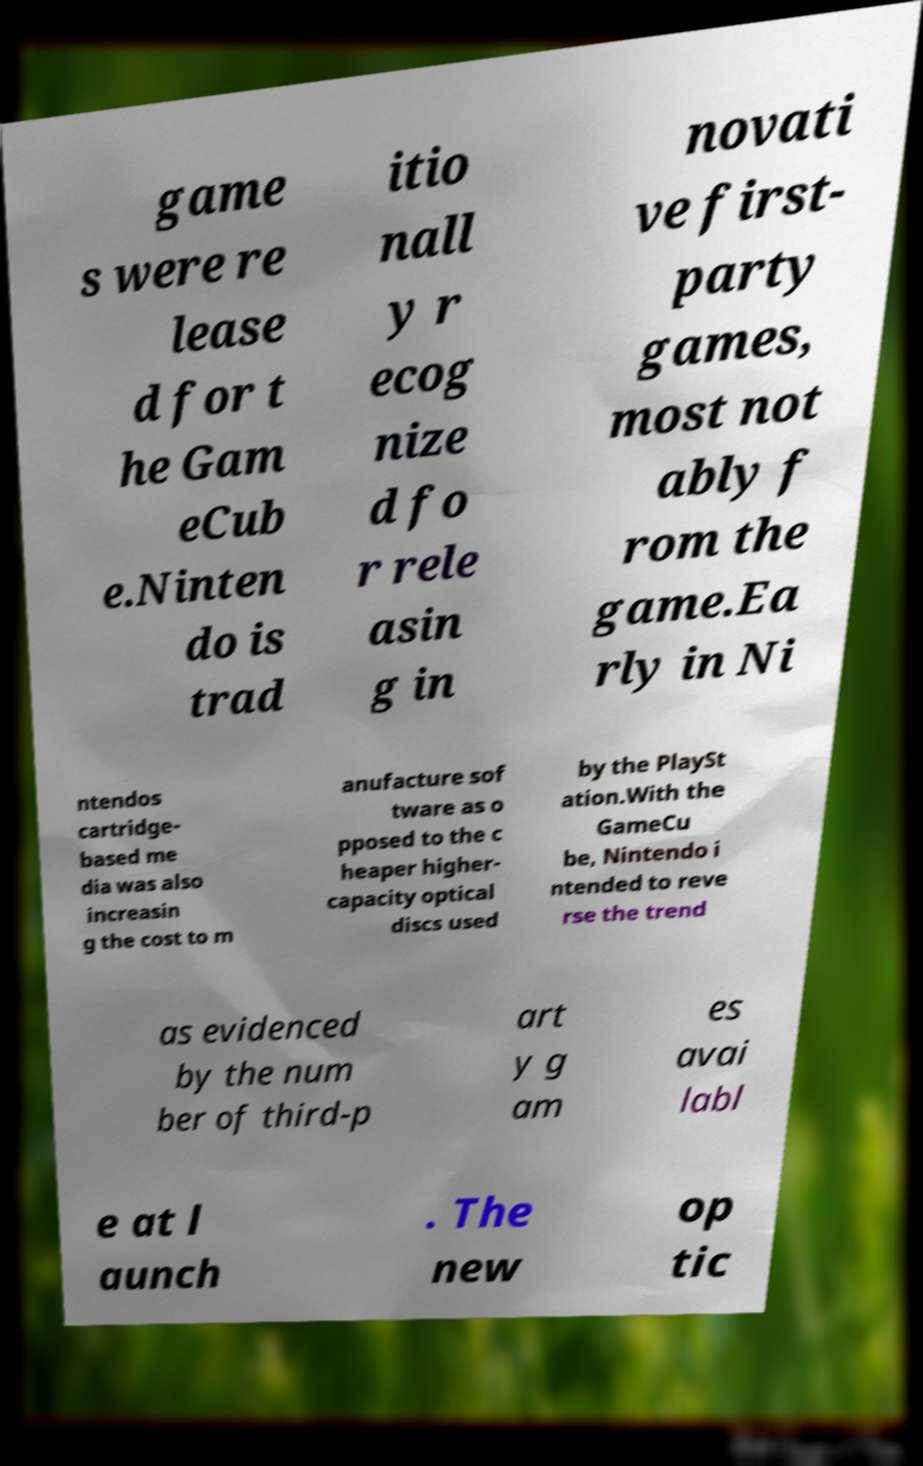Could you assist in decoding the text presented in this image and type it out clearly? game s were re lease d for t he Gam eCub e.Ninten do is trad itio nall y r ecog nize d fo r rele asin g in novati ve first- party games, most not ably f rom the game.Ea rly in Ni ntendos cartridge- based me dia was also increasin g the cost to m anufacture sof tware as o pposed to the c heaper higher- capacity optical discs used by the PlaySt ation.With the GameCu be, Nintendo i ntended to reve rse the trend as evidenced by the num ber of third-p art y g am es avai labl e at l aunch . The new op tic 